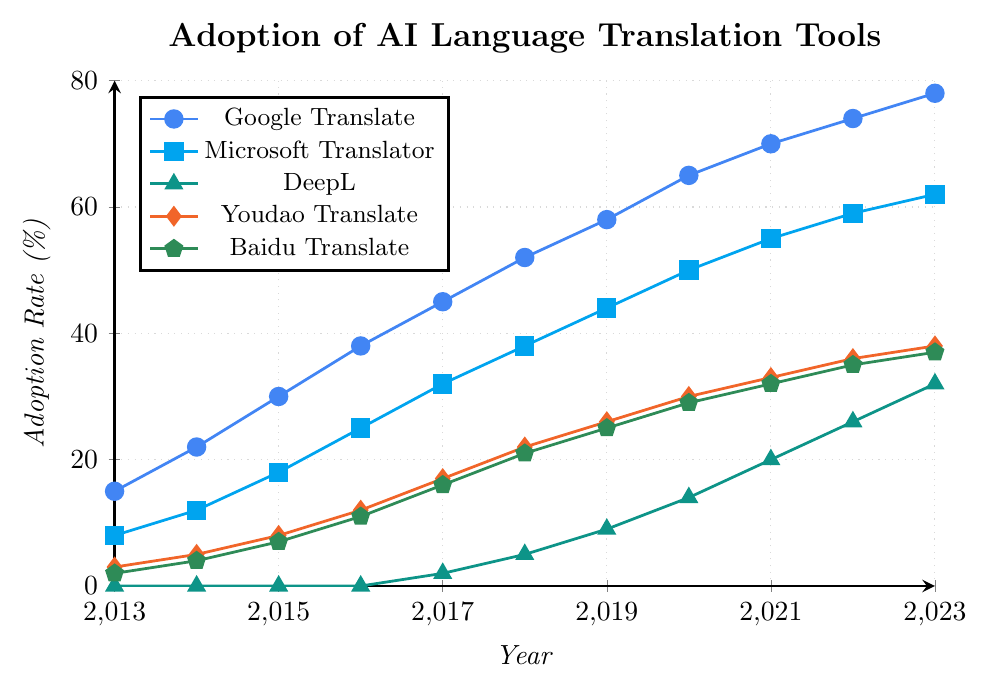What's the adoption rate difference between Google Translate and DeepL in 2023? In 2023, Google Translate's adoption rate is 78% and DeepL's is 32%. The difference is 78 - 32.
Answer: 46% Between 2013 and 2023, which language translation tool consistently showed an increase in adoption rate every year? Checking each tool, we find that Google Translate, Microsoft Translator, Youdao Translate, and Baidu Translate show yearly increases. DeepL also increases but starts from 0 in 2013-2016.
Answer: Google Translate, Microsoft Translator, Youdao Translate, Baidu Translate In what year did Youdao Translate surpass Baidu Translate in adoption rate? Comparing the rates for each year, Youdao Translate surpasses Baidu Translate in 2016 when Youdao is at 12% and Baidu is at 11%.
Answer: 2016 How much did Microsoft Translator grow from 2013 to 2018? Microsoft's rate in 2013 is 8%, and in 2018 it is 38%. The growth is 38 - 8.
Answer: 30% What is the average adoption rate of Google Translate from 2013 to 2023? Sum Google Translate's adoption rates for each year (15 + 22 + 30 + 38 + 45 + 52 + 58 + 65 + 70 + 74 + 78) which is 547, then divide by 11 (number of years) to get the average.
Answer: 49.73% Which translation tool has the highest adoption rate in 2020 and what is the value? Referring to the 2020 values, Google Translate has the highest adoption rate at 65%.
Answer: Google Translate, 65% What trend can be observed for DeepL from 2017 to 2023? DeepL starts at 2% in 2017 and consistently increases every year up to 32% in 2023.
Answer: Consistent increase By how much did Youdao Translate's adoption rate increase from 2016 to 2023? In 2016, the rate was 12%, and in 2023 it is 38%. The increase is 38 - 12.
Answer: 26% Which language translation tool had the lowest adoption rate in 2015, and what was the rate? Referring to the 2015 values, DeepL had 0%, the lowest.
Answer: DeepL, 0% 